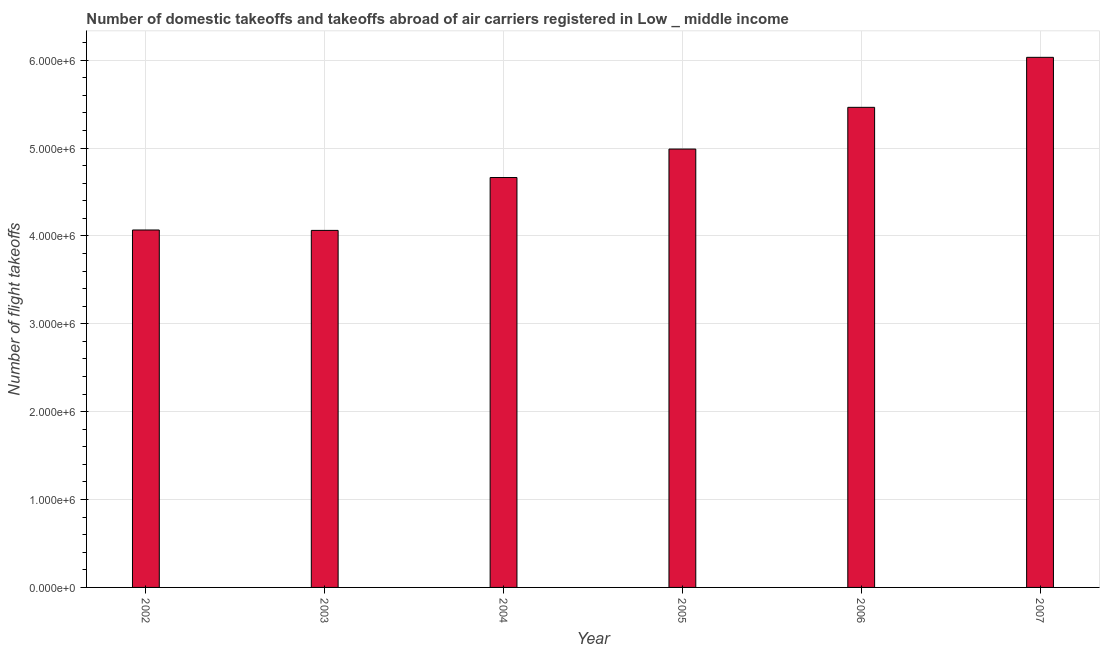Does the graph contain grids?
Provide a short and direct response. Yes. What is the title of the graph?
Provide a short and direct response. Number of domestic takeoffs and takeoffs abroad of air carriers registered in Low _ middle income. What is the label or title of the X-axis?
Offer a terse response. Year. What is the label or title of the Y-axis?
Keep it short and to the point. Number of flight takeoffs. What is the number of flight takeoffs in 2006?
Provide a short and direct response. 5.46e+06. Across all years, what is the maximum number of flight takeoffs?
Offer a very short reply. 6.03e+06. Across all years, what is the minimum number of flight takeoffs?
Give a very brief answer. 4.06e+06. What is the sum of the number of flight takeoffs?
Your response must be concise. 2.93e+07. What is the difference between the number of flight takeoffs in 2005 and 2007?
Provide a succinct answer. -1.04e+06. What is the average number of flight takeoffs per year?
Make the answer very short. 4.88e+06. What is the median number of flight takeoffs?
Ensure brevity in your answer.  4.83e+06. In how many years, is the number of flight takeoffs greater than 1000000 ?
Ensure brevity in your answer.  6. Do a majority of the years between 2003 and 2006 (inclusive) have number of flight takeoffs greater than 4600000 ?
Your answer should be very brief. Yes. What is the ratio of the number of flight takeoffs in 2002 to that in 2004?
Your answer should be compact. 0.87. Is the number of flight takeoffs in 2002 less than that in 2004?
Offer a terse response. Yes. What is the difference between the highest and the second highest number of flight takeoffs?
Your response must be concise. 5.69e+05. Is the sum of the number of flight takeoffs in 2002 and 2003 greater than the maximum number of flight takeoffs across all years?
Give a very brief answer. Yes. What is the difference between the highest and the lowest number of flight takeoffs?
Your answer should be compact. 1.97e+06. In how many years, is the number of flight takeoffs greater than the average number of flight takeoffs taken over all years?
Ensure brevity in your answer.  3. How many years are there in the graph?
Your answer should be compact. 6. What is the difference between two consecutive major ticks on the Y-axis?
Offer a terse response. 1.00e+06. What is the Number of flight takeoffs in 2002?
Provide a short and direct response. 4.07e+06. What is the Number of flight takeoffs in 2003?
Keep it short and to the point. 4.06e+06. What is the Number of flight takeoffs in 2004?
Offer a very short reply. 4.66e+06. What is the Number of flight takeoffs in 2005?
Offer a very short reply. 4.99e+06. What is the Number of flight takeoffs of 2006?
Your response must be concise. 5.46e+06. What is the Number of flight takeoffs of 2007?
Make the answer very short. 6.03e+06. What is the difference between the Number of flight takeoffs in 2002 and 2003?
Provide a succinct answer. 4485. What is the difference between the Number of flight takeoffs in 2002 and 2004?
Ensure brevity in your answer.  -5.97e+05. What is the difference between the Number of flight takeoffs in 2002 and 2005?
Your answer should be compact. -9.21e+05. What is the difference between the Number of flight takeoffs in 2002 and 2006?
Keep it short and to the point. -1.40e+06. What is the difference between the Number of flight takeoffs in 2002 and 2007?
Your answer should be very brief. -1.96e+06. What is the difference between the Number of flight takeoffs in 2003 and 2004?
Provide a succinct answer. -6.02e+05. What is the difference between the Number of flight takeoffs in 2003 and 2005?
Provide a succinct answer. -9.26e+05. What is the difference between the Number of flight takeoffs in 2003 and 2006?
Provide a short and direct response. -1.40e+06. What is the difference between the Number of flight takeoffs in 2003 and 2007?
Your answer should be very brief. -1.97e+06. What is the difference between the Number of flight takeoffs in 2004 and 2005?
Your answer should be compact. -3.24e+05. What is the difference between the Number of flight takeoffs in 2004 and 2006?
Ensure brevity in your answer.  -7.99e+05. What is the difference between the Number of flight takeoffs in 2004 and 2007?
Offer a very short reply. -1.37e+06. What is the difference between the Number of flight takeoffs in 2005 and 2006?
Offer a terse response. -4.75e+05. What is the difference between the Number of flight takeoffs in 2005 and 2007?
Make the answer very short. -1.04e+06. What is the difference between the Number of flight takeoffs in 2006 and 2007?
Your answer should be compact. -5.69e+05. What is the ratio of the Number of flight takeoffs in 2002 to that in 2003?
Your answer should be compact. 1. What is the ratio of the Number of flight takeoffs in 2002 to that in 2004?
Offer a terse response. 0.87. What is the ratio of the Number of flight takeoffs in 2002 to that in 2005?
Provide a succinct answer. 0.81. What is the ratio of the Number of flight takeoffs in 2002 to that in 2006?
Your answer should be very brief. 0.74. What is the ratio of the Number of flight takeoffs in 2002 to that in 2007?
Provide a succinct answer. 0.67. What is the ratio of the Number of flight takeoffs in 2003 to that in 2004?
Ensure brevity in your answer.  0.87. What is the ratio of the Number of flight takeoffs in 2003 to that in 2005?
Offer a terse response. 0.81. What is the ratio of the Number of flight takeoffs in 2003 to that in 2006?
Offer a very short reply. 0.74. What is the ratio of the Number of flight takeoffs in 2003 to that in 2007?
Provide a succinct answer. 0.67. What is the ratio of the Number of flight takeoffs in 2004 to that in 2005?
Make the answer very short. 0.94. What is the ratio of the Number of flight takeoffs in 2004 to that in 2006?
Keep it short and to the point. 0.85. What is the ratio of the Number of flight takeoffs in 2004 to that in 2007?
Keep it short and to the point. 0.77. What is the ratio of the Number of flight takeoffs in 2005 to that in 2007?
Keep it short and to the point. 0.83. What is the ratio of the Number of flight takeoffs in 2006 to that in 2007?
Offer a very short reply. 0.91. 